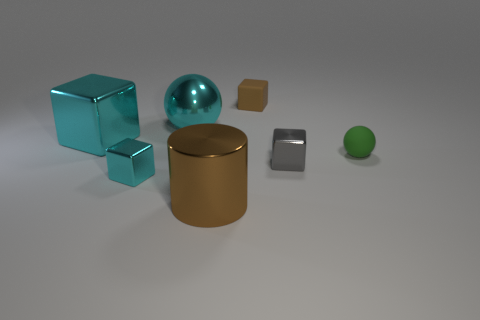The small brown matte object has what shape?
Your response must be concise. Cube. Does the small rubber object that is behind the small green thing have the same color as the metallic ball?
Ensure brevity in your answer.  No. There is a gray metal thing that is the same shape as the small brown rubber thing; what is its size?
Make the answer very short. Small. Is there anything else that has the same material as the big block?
Your response must be concise. Yes. Are there any large cyan balls that are behind the big cyan object that is to the right of the small shiny block to the left of the big cylinder?
Offer a very short reply. No. There is a cyan block behind the gray metallic thing; what is its material?
Your answer should be compact. Metal. What number of tiny things are balls or cylinders?
Ensure brevity in your answer.  1. There is a cube on the right side of the brown cube; is it the same size as the metal sphere?
Offer a very short reply. No. How many other objects are the same color as the big cylinder?
Provide a short and direct response. 1. What is the big sphere made of?
Give a very brief answer. Metal. 